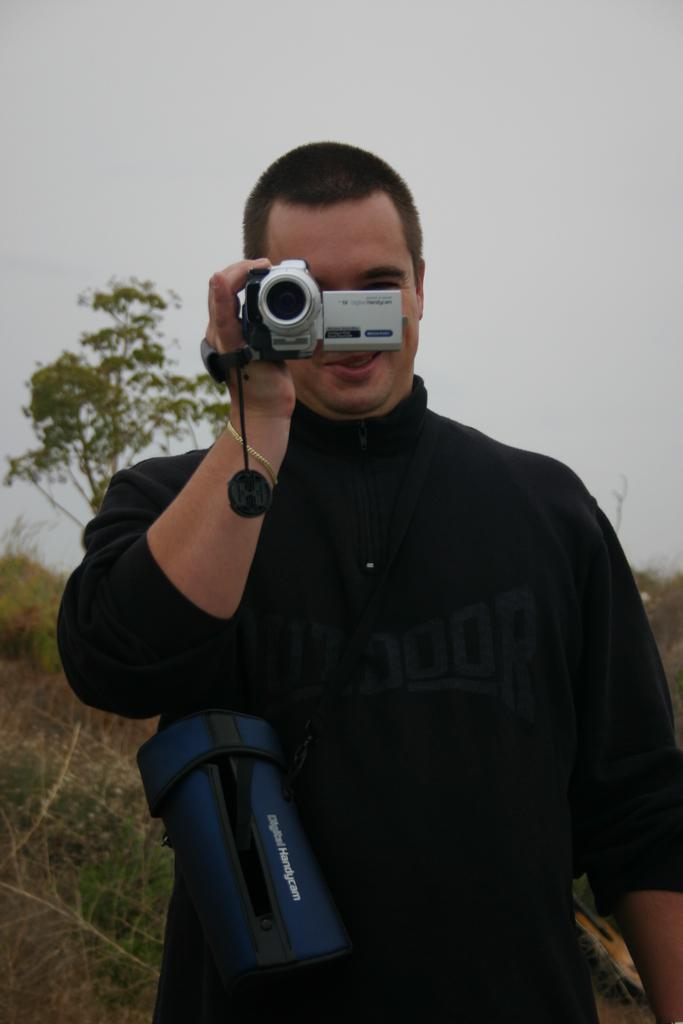What can be seen in the background of the image? There is a sky and trees visible in the background of the image. What is the man in the image doing? The man is standing in the image and recording with a camera that he is holding in his hands. What color is the bag in the image? The bag in the image is blue. What type of cream is being used to create the magic in the image? There is no cream or magic present in the image; it features a man holding a camera and standing in front of a sky and trees. How does the toothpaste contribute to the man's photography in the image? There is no toothpaste present in the image, and it does not contribute to the man's photography. 